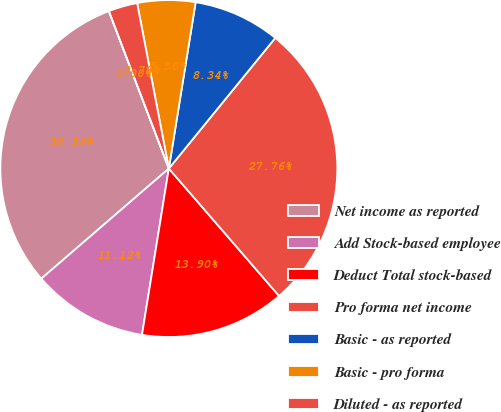Convert chart to OTSL. <chart><loc_0><loc_0><loc_500><loc_500><pie_chart><fcel>Net income as reported<fcel>Add Stock-based employee<fcel>Deduct Total stock-based<fcel>Pro forma net income<fcel>Basic - as reported<fcel>Basic - pro forma<fcel>Diluted - as reported<fcel>Diluted - pro forma<nl><fcel>30.55%<fcel>11.12%<fcel>13.9%<fcel>27.77%<fcel>8.34%<fcel>5.56%<fcel>2.78%<fcel>0.0%<nl></chart> 